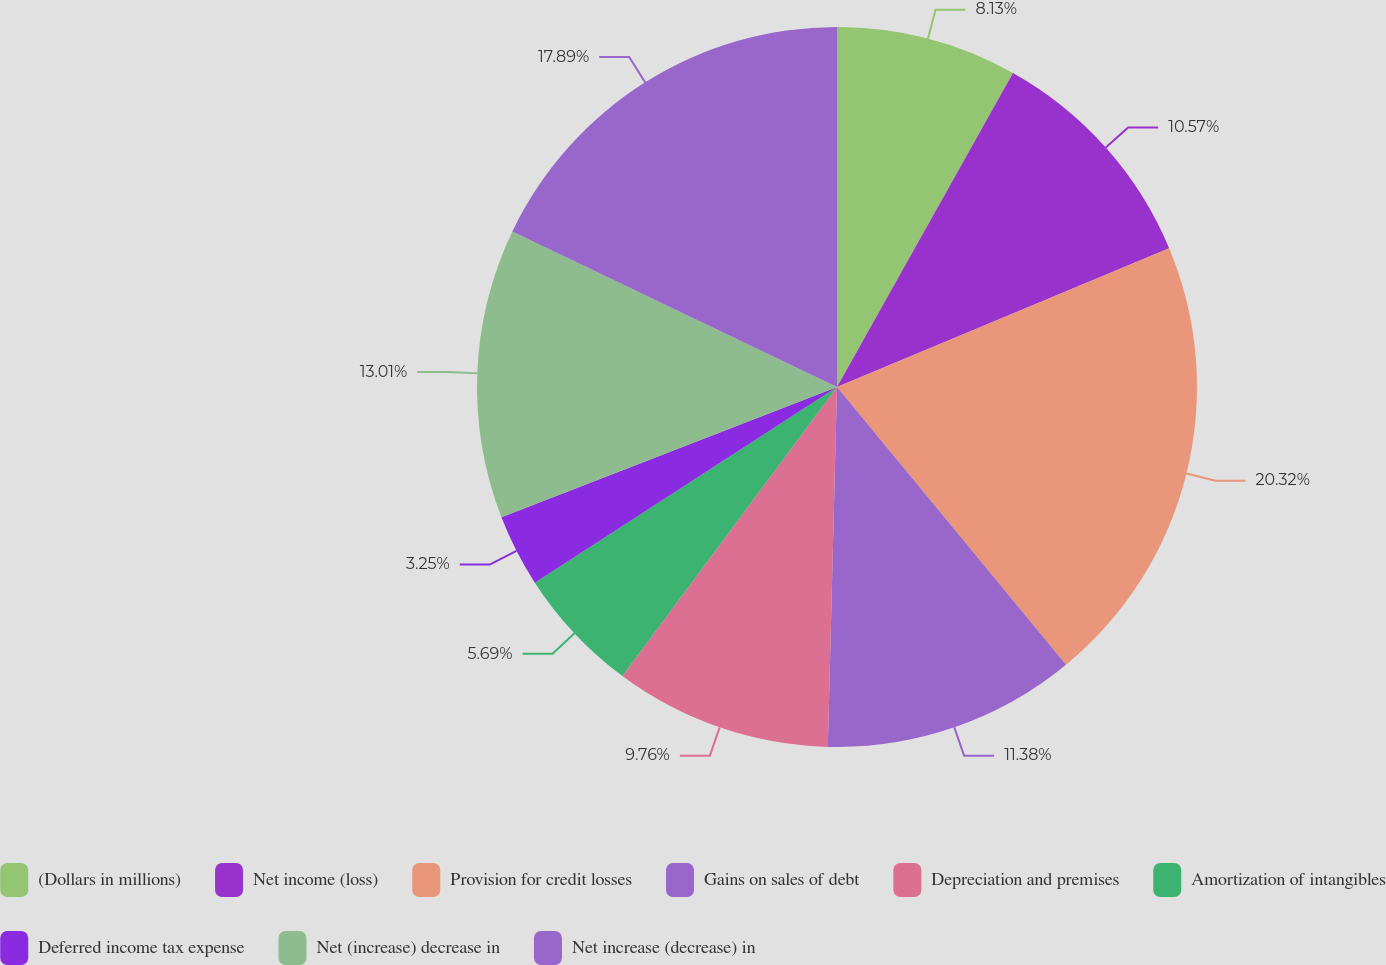Convert chart to OTSL. <chart><loc_0><loc_0><loc_500><loc_500><pie_chart><fcel>(Dollars in millions)<fcel>Net income (loss)<fcel>Provision for credit losses<fcel>Gains on sales of debt<fcel>Depreciation and premises<fcel>Amortization of intangibles<fcel>Deferred income tax expense<fcel>Net (increase) decrease in<fcel>Net increase (decrease) in<nl><fcel>8.13%<fcel>10.57%<fcel>20.33%<fcel>11.38%<fcel>9.76%<fcel>5.69%<fcel>3.25%<fcel>13.01%<fcel>17.89%<nl></chart> 